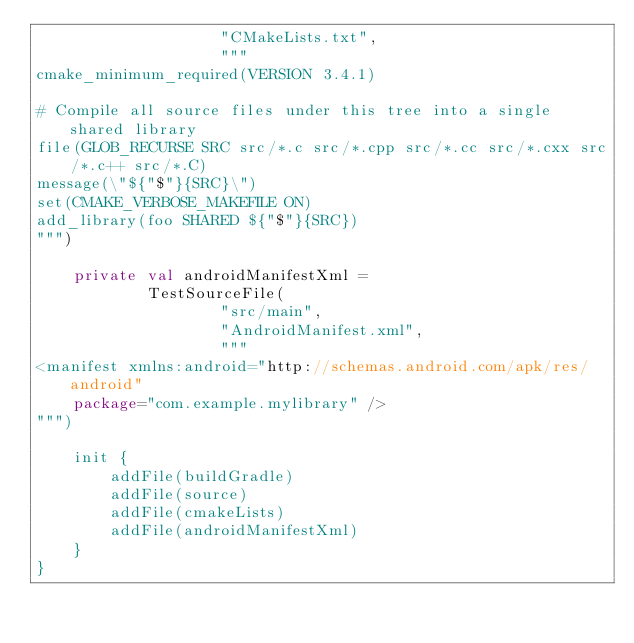Convert code to text. <code><loc_0><loc_0><loc_500><loc_500><_Kotlin_>                    "CMakeLists.txt",
                    """
cmake_minimum_required(VERSION 3.4.1)

# Compile all source files under this tree into a single shared library
file(GLOB_RECURSE SRC src/*.c src/*.cpp src/*.cc src/*.cxx src/*.c++ src/*.C)
message(\"${"$"}{SRC}\")
set(CMAKE_VERBOSE_MAKEFILE ON)
add_library(foo SHARED ${"$"}{SRC})
""")

    private val androidManifestXml =
            TestSourceFile(
                    "src/main",
                    "AndroidManifest.xml",
                    """
<manifest xmlns:android="http://schemas.android.com/apk/res/android"
    package="com.example.mylibrary" />
""")

    init {
        addFile(buildGradle)
        addFile(source)
        addFile(cmakeLists)
        addFile(androidManifestXml)
    }
}</code> 